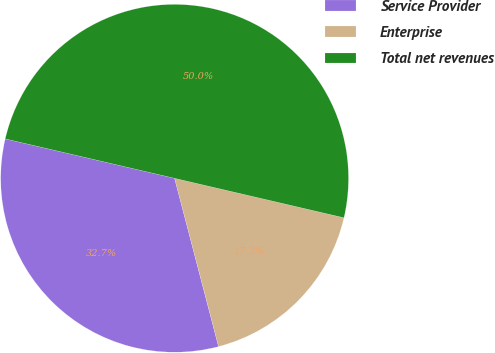Convert chart. <chart><loc_0><loc_0><loc_500><loc_500><pie_chart><fcel>Service Provider<fcel>Enterprise<fcel>Total net revenues<nl><fcel>32.71%<fcel>17.29%<fcel>50.0%<nl></chart> 